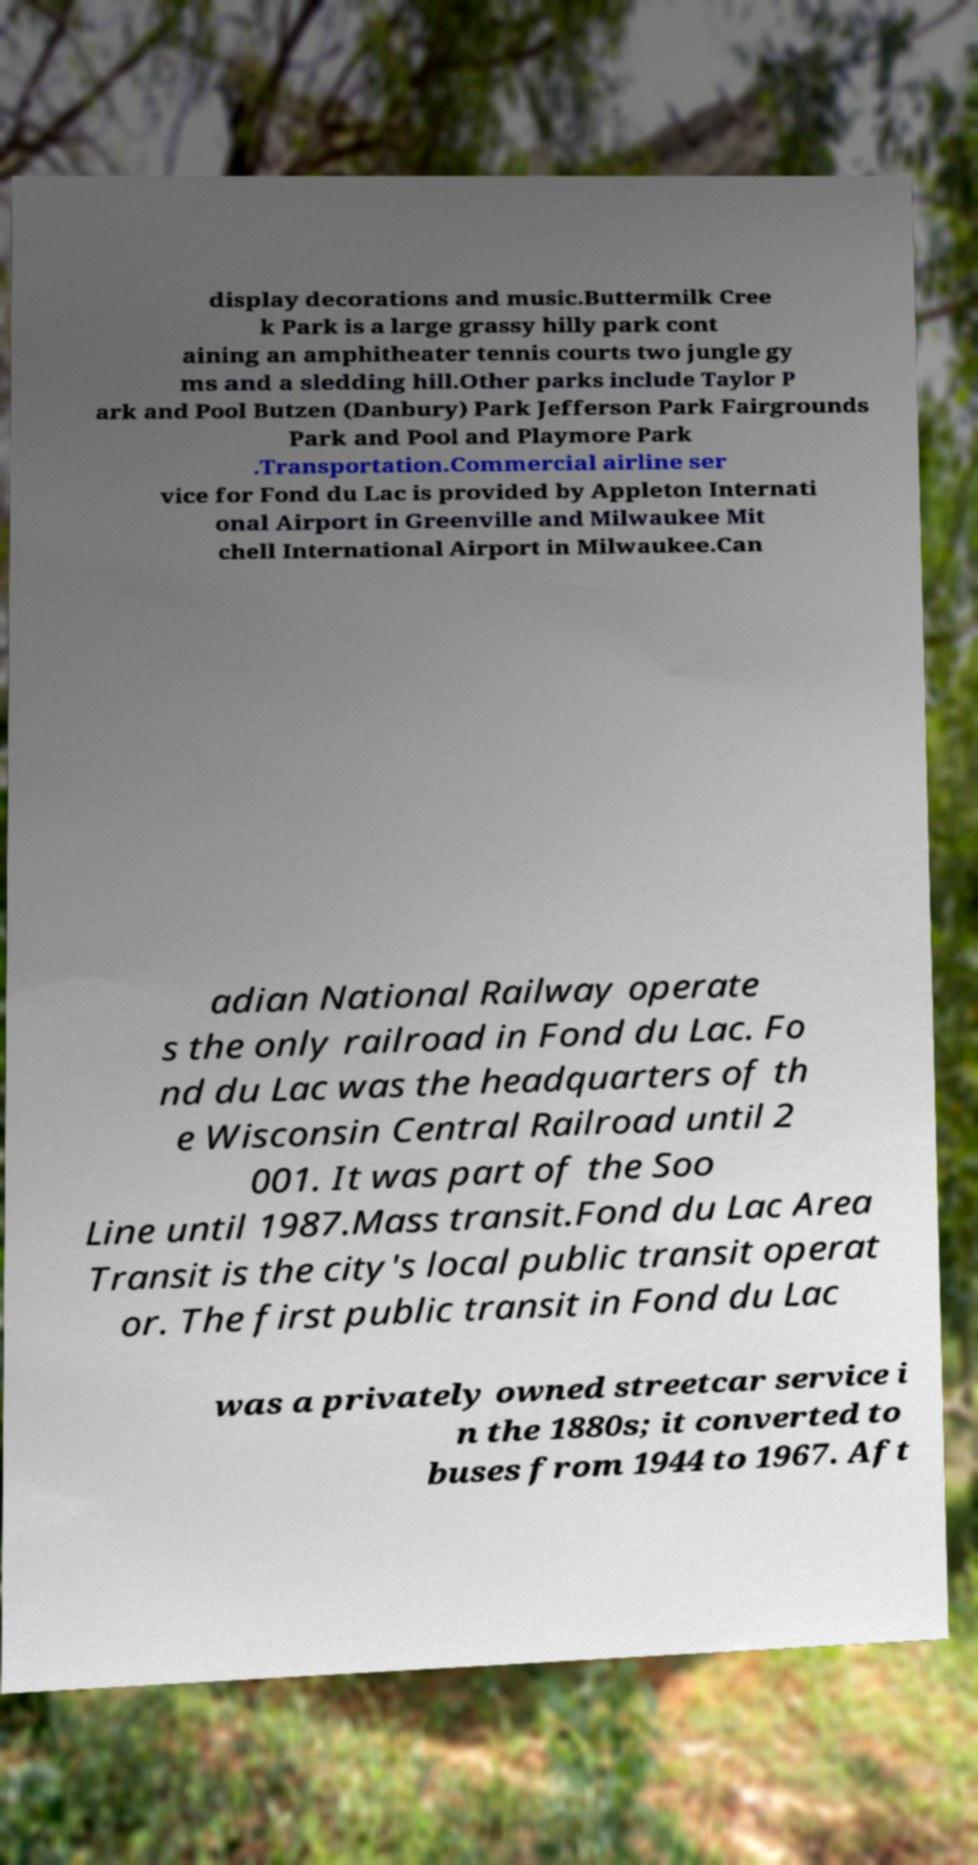There's text embedded in this image that I need extracted. Can you transcribe it verbatim? display decorations and music.Buttermilk Cree k Park is a large grassy hilly park cont aining an amphitheater tennis courts two jungle gy ms and a sledding hill.Other parks include Taylor P ark and Pool Butzen (Danbury) Park Jefferson Park Fairgrounds Park and Pool and Playmore Park .Transportation.Commercial airline ser vice for Fond du Lac is provided by Appleton Internati onal Airport in Greenville and Milwaukee Mit chell International Airport in Milwaukee.Can adian National Railway operate s the only railroad in Fond du Lac. Fo nd du Lac was the headquarters of th e Wisconsin Central Railroad until 2 001. It was part of the Soo Line until 1987.Mass transit.Fond du Lac Area Transit is the city's local public transit operat or. The first public transit in Fond du Lac was a privately owned streetcar service i n the 1880s; it converted to buses from 1944 to 1967. Aft 